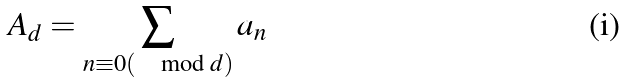<formula> <loc_0><loc_0><loc_500><loc_500>A _ { d } = \sum _ { n \equiv 0 ( \mod d ) } a _ { n }</formula> 